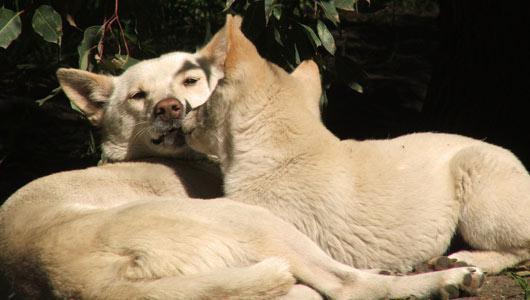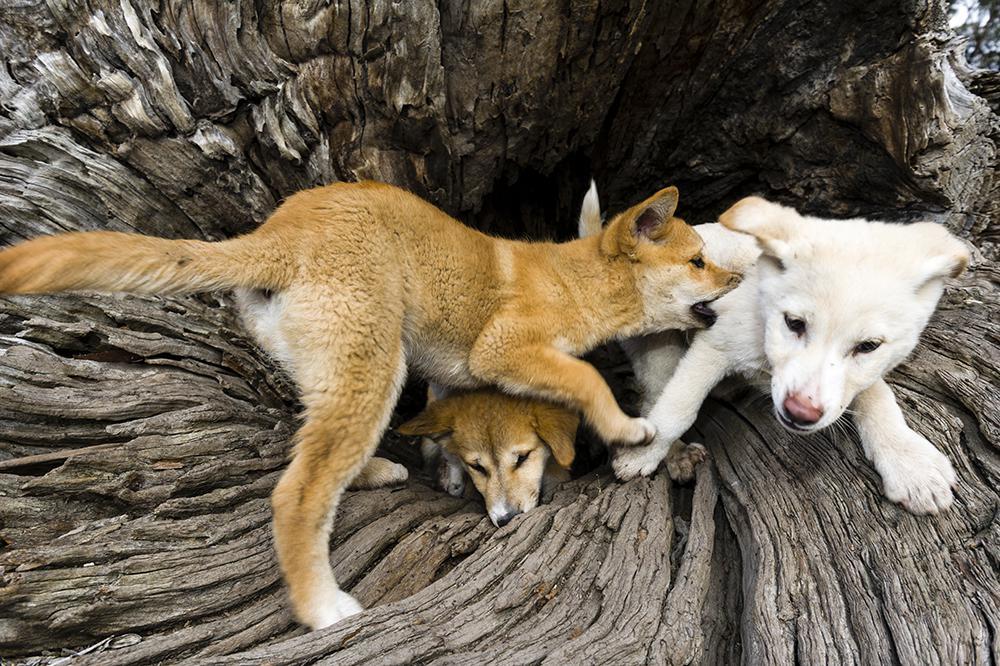The first image is the image on the left, the second image is the image on the right. For the images shown, is this caption "There ais at least one dog standing on a rocky hill" true? Answer yes or no. No. The first image is the image on the left, the second image is the image on the right. Considering the images on both sides, is "There appear to be exactly eight dogs." valid? Answer yes or no. No. 